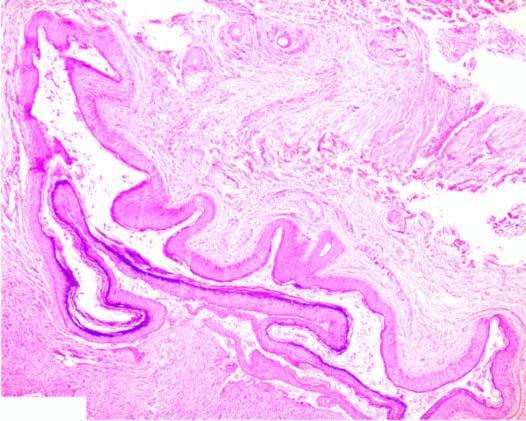what does dermoid cyst have?
Answer the question using a single word or phrase. Adnexal structures in the cyst wall 